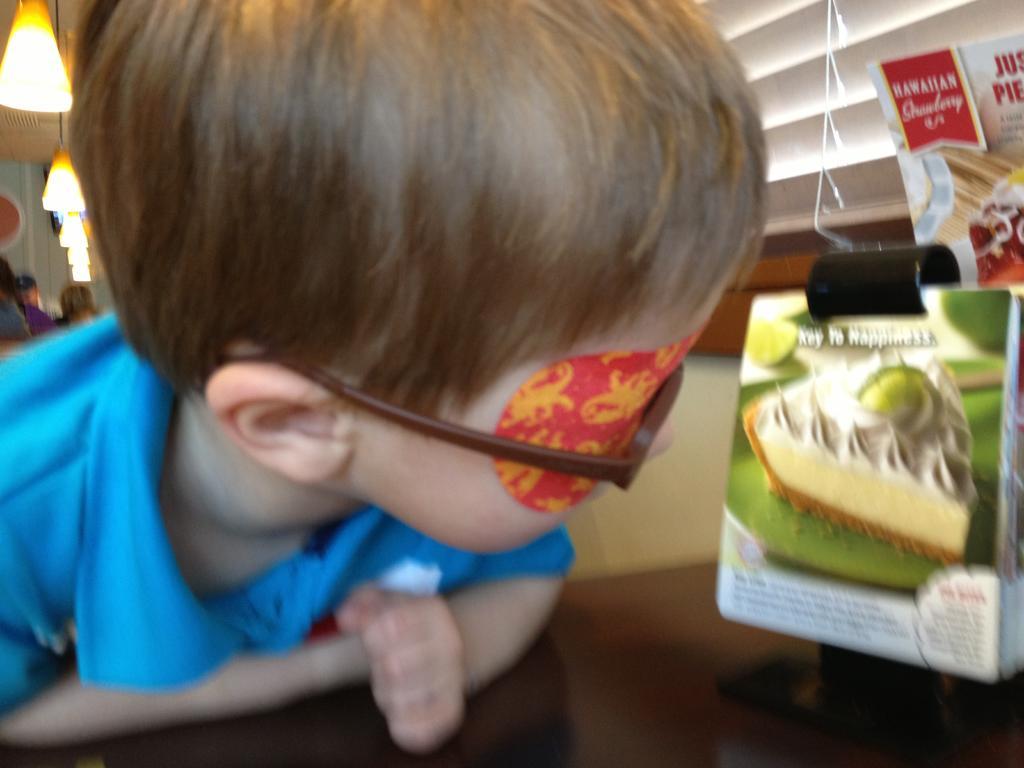Describe this image in one or two sentences. On the left side, there is a boy in blue color T-shirt, leaning on a table, on which there are posters arranged. In the background, there are lights, persons and other objects. 